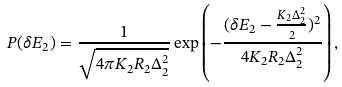<formula> <loc_0><loc_0><loc_500><loc_500>P ( \delta E _ { 2 } ) = \frac { 1 } { \sqrt { 4 \pi K _ { 2 } R _ { 2 } \Delta _ { 2 } ^ { 2 } } } \exp \left ( - \frac { ( \delta E _ { 2 } - \frac { K _ { 2 } \Delta _ { 2 } ^ { 2 } } { 2 } ) ^ { 2 } } { 4 K _ { 2 } R _ { 2 } \Delta _ { 2 } ^ { 2 } } \right ) ,</formula> 